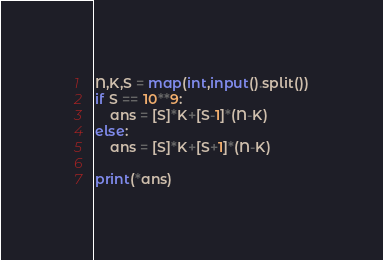<code> <loc_0><loc_0><loc_500><loc_500><_Python_>N,K,S = map(int,input().split())
if S == 10**9:
    ans = [S]*K+[S-1]*(N-K)
else:
    ans = [S]*K+[S+1]*(N-K)

print(*ans)</code> 